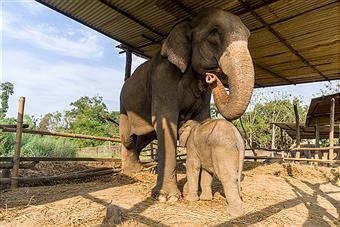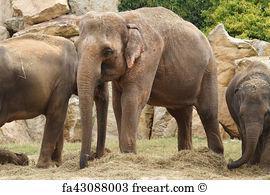The first image is the image on the left, the second image is the image on the right. For the images displayed, is the sentence "An image shows one small elephant with its head poking under the legs of an adult elephant with a curled trunk." factually correct? Answer yes or no. Yes. 